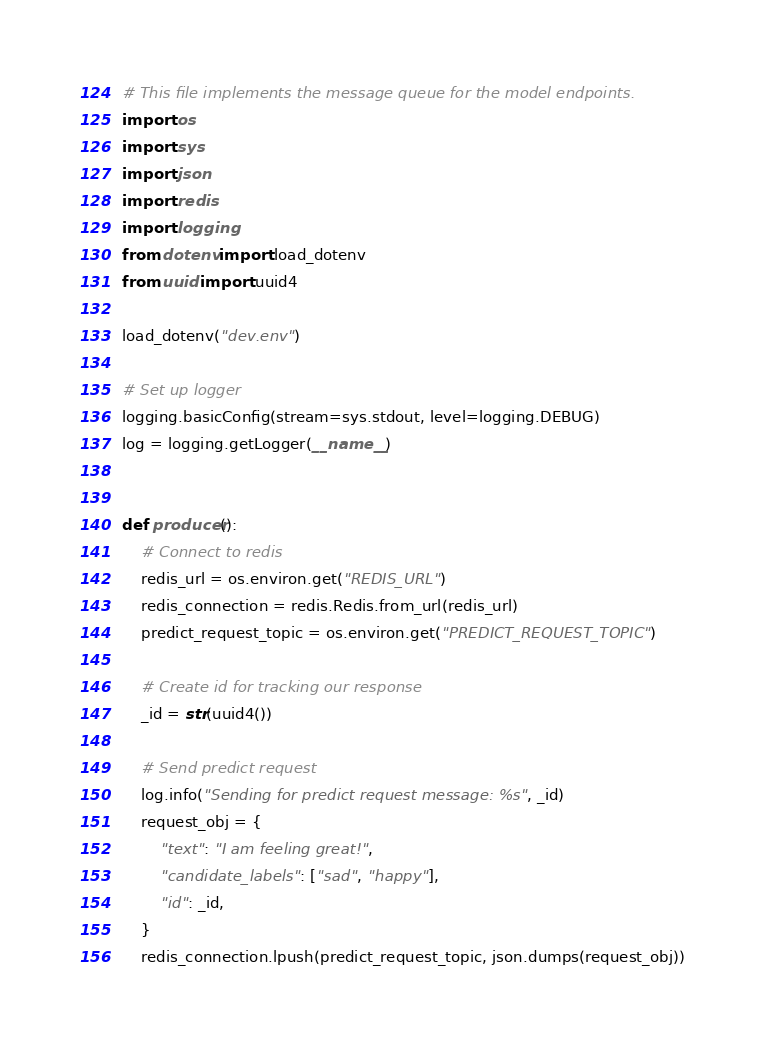Convert code to text. <code><loc_0><loc_0><loc_500><loc_500><_Python_># This file implements the message queue for the model endpoints.
import os
import sys
import json
import redis
import logging
from dotenv import load_dotenv
from uuid import uuid4

load_dotenv("dev.env")

# Set up logger
logging.basicConfig(stream=sys.stdout, level=logging.DEBUG)
log = logging.getLogger(__name__)


def producer():
    # Connect to redis
    redis_url = os.environ.get("REDIS_URL")
    redis_connection = redis.Redis.from_url(redis_url)
    predict_request_topic = os.environ.get("PREDICT_REQUEST_TOPIC")

    # Create id for tracking our response
    _id = str(uuid4())

    # Send predict request
    log.info("Sending for predict request message: %s", _id)
    request_obj = {
        "text": "I am feeling great!",
        "candidate_labels": ["sad", "happy"],
        "id": _id,
    }
    redis_connection.lpush(predict_request_topic, json.dumps(request_obj))
</code> 